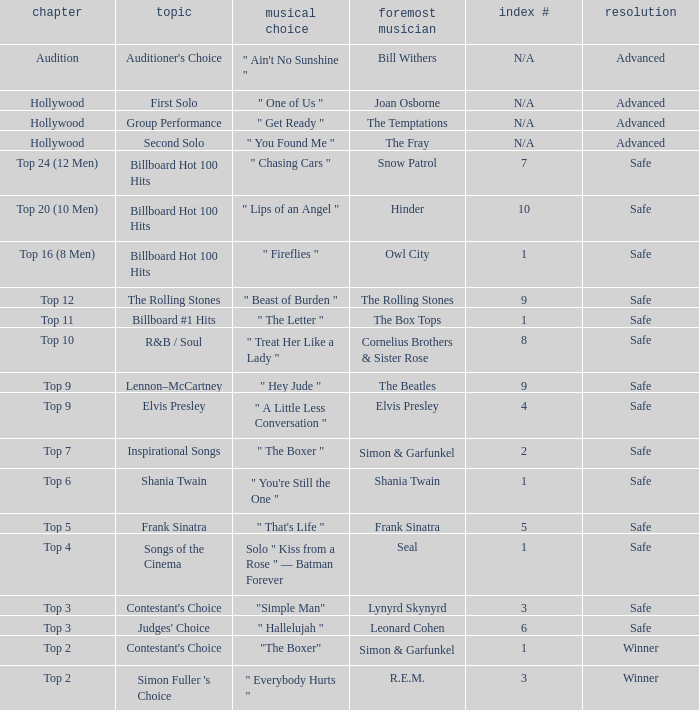Who is the original artist of the song choice " The Letter "? The Box Tops. 